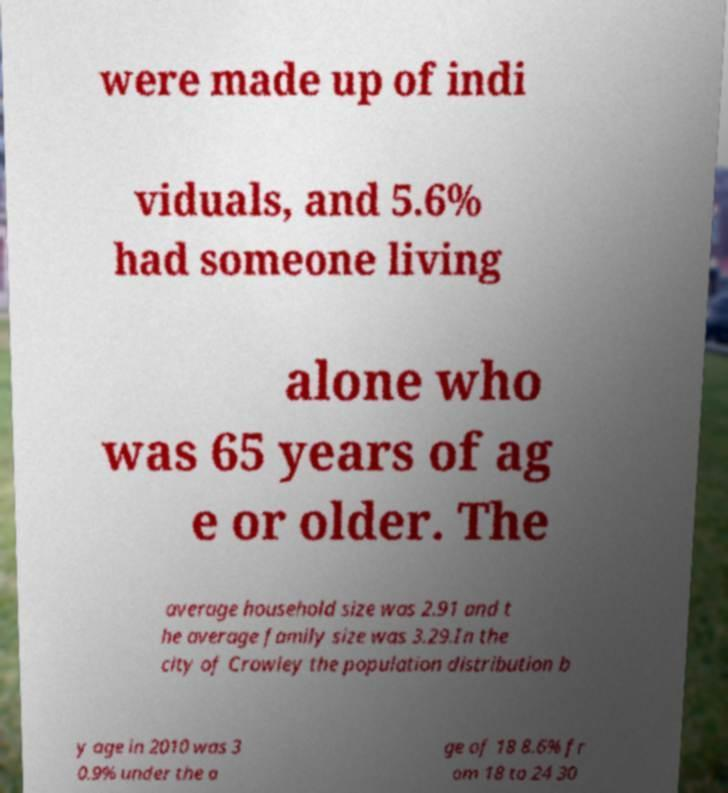I need the written content from this picture converted into text. Can you do that? were made up of indi viduals, and 5.6% had someone living alone who was 65 years of ag e or older. The average household size was 2.91 and t he average family size was 3.29.In the city of Crowley the population distribution b y age in 2010 was 3 0.9% under the a ge of 18 8.6% fr om 18 to 24 30 